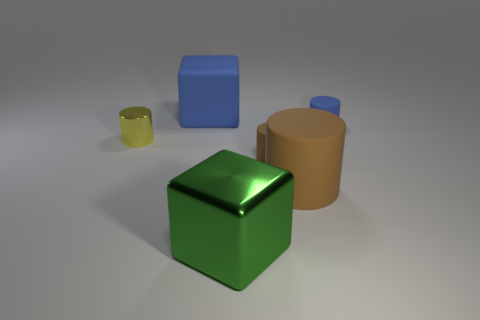Add 1 blue blocks. How many objects exist? 7 Subtract all small brown cylinders. How many cylinders are left? 3 Subtract all blue cubes. How many cubes are left? 1 Subtract all blocks. How many objects are left? 4 Subtract 0 purple cylinders. How many objects are left? 6 Subtract 2 cubes. How many cubes are left? 0 Subtract all blue blocks. Subtract all cyan cylinders. How many blocks are left? 1 Subtract all blue cylinders. How many green cubes are left? 1 Subtract all brown matte things. Subtract all large brown rubber objects. How many objects are left? 3 Add 5 brown cylinders. How many brown cylinders are left? 7 